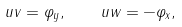Convert formula to latex. <formula><loc_0><loc_0><loc_500><loc_500>u v = \varphi _ { y } , \quad u w = - \varphi _ { x } ,</formula> 